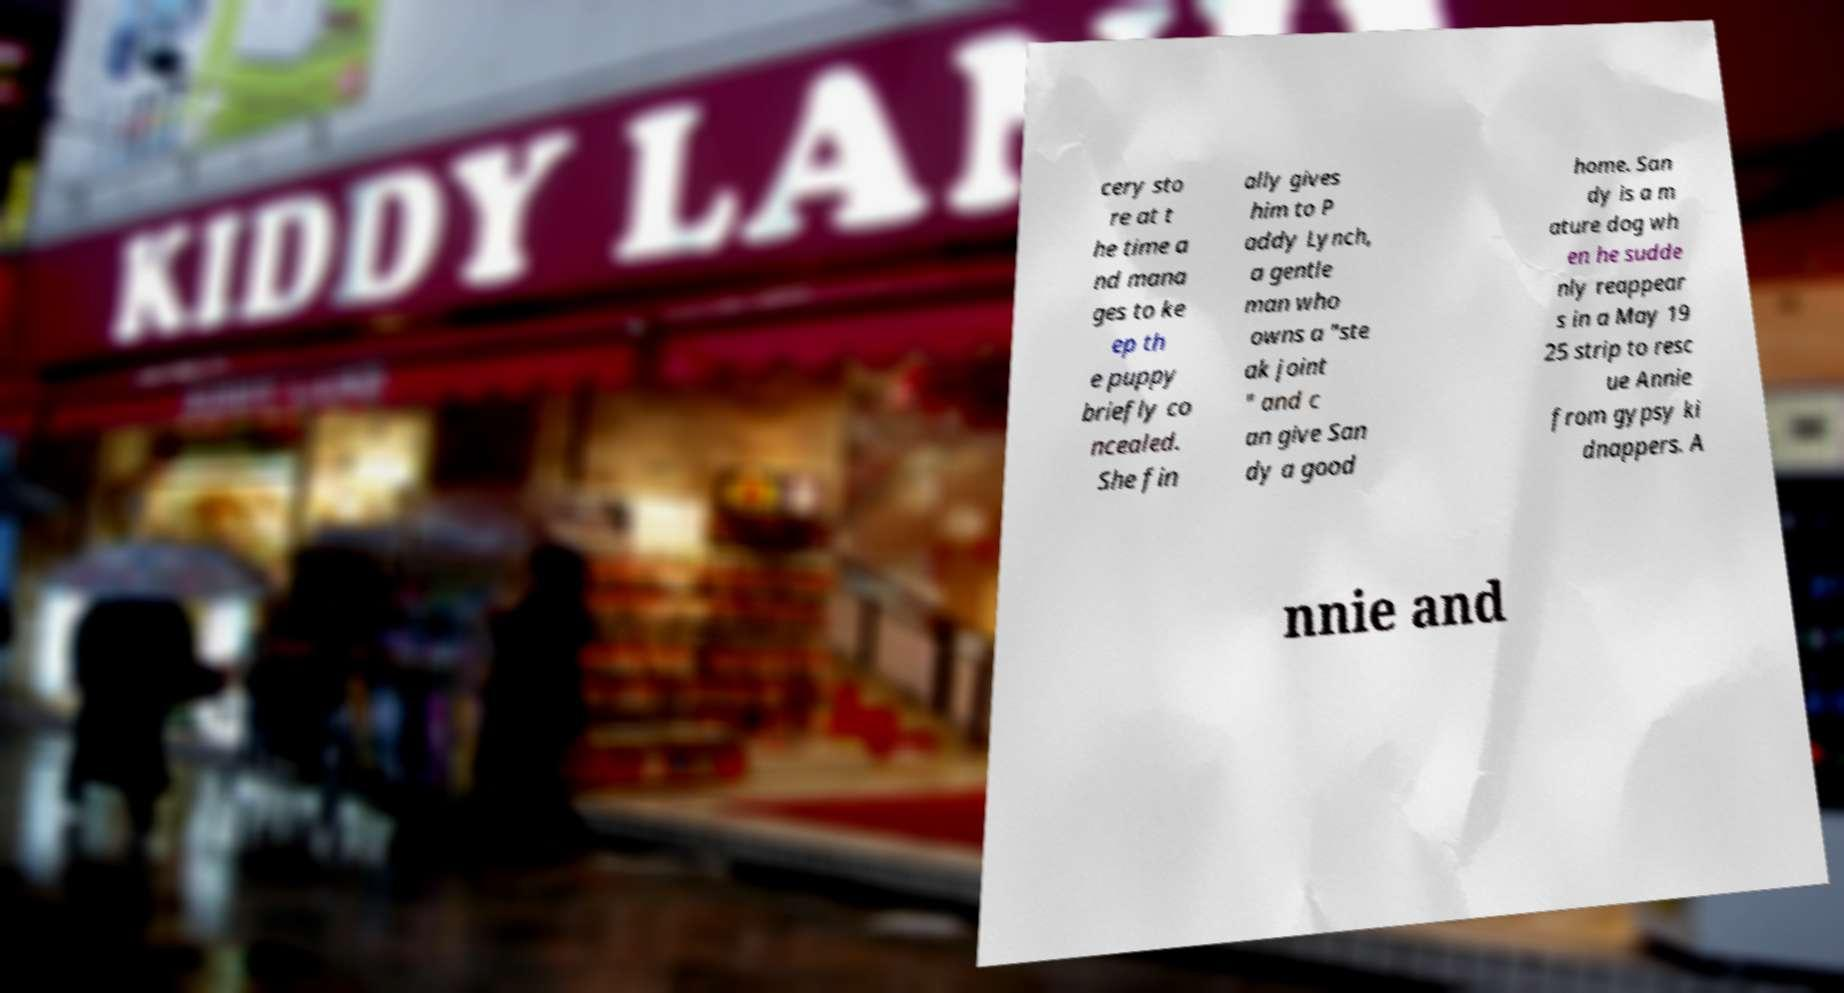Please identify and transcribe the text found in this image. cery sto re at t he time a nd mana ges to ke ep th e puppy briefly co ncealed. She fin ally gives him to P addy Lynch, a gentle man who owns a "ste ak joint " and c an give San dy a good home. San dy is a m ature dog wh en he sudde nly reappear s in a May 19 25 strip to resc ue Annie from gypsy ki dnappers. A nnie and 